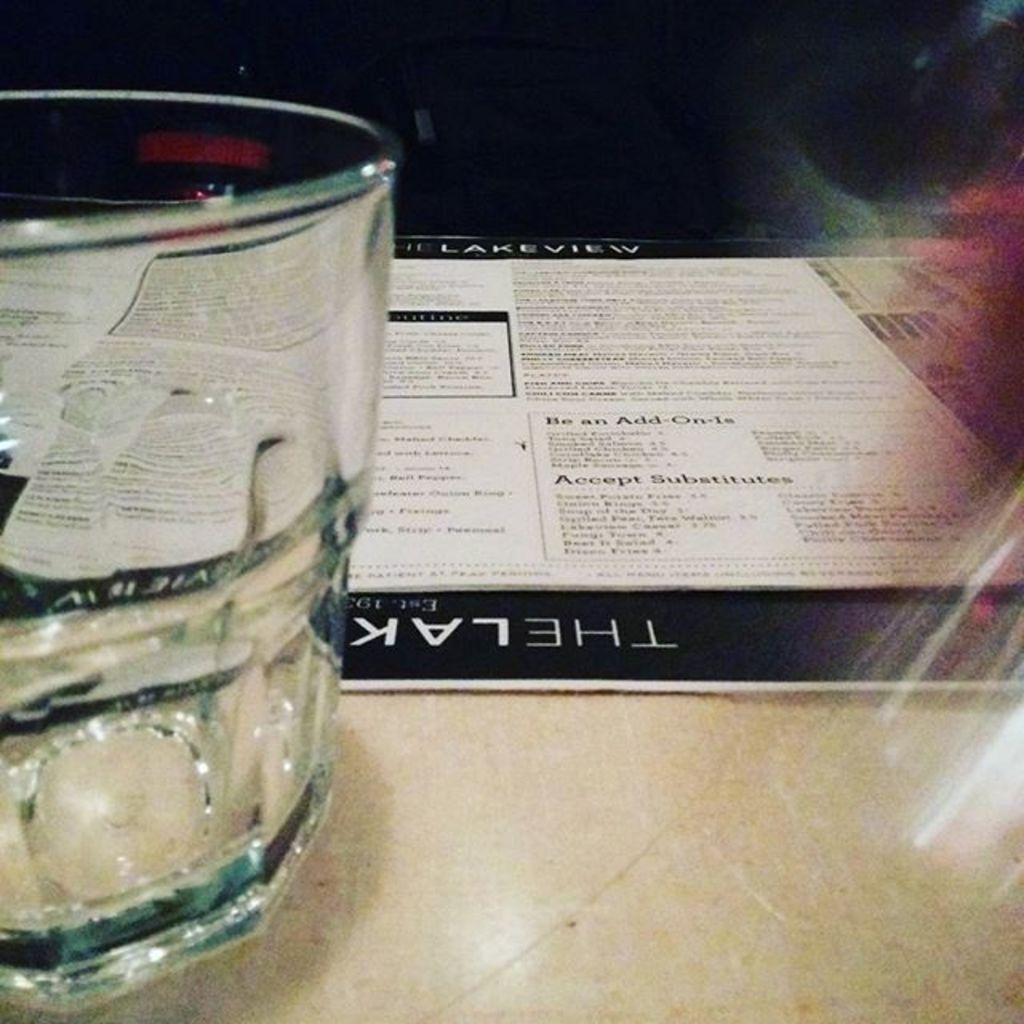<image>
Write a terse but informative summary of the picture. The Lakeview menu with add ons and substitues. 